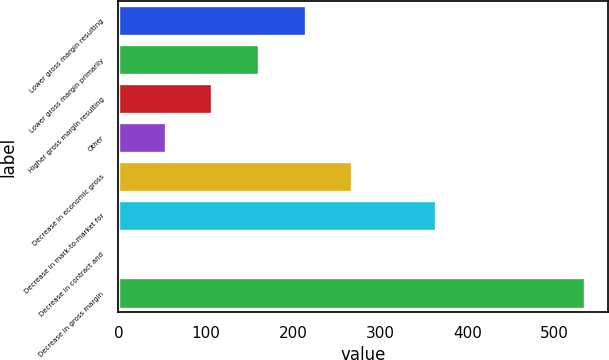<chart> <loc_0><loc_0><loc_500><loc_500><bar_chart><fcel>Lower gross margin resulting<fcel>Lower gross margin primarily<fcel>Higher gross margin resulting<fcel>Other<fcel>Decrease in economic gross<fcel>Decrease in mark-to-market for<fcel>Decrease in contract and<fcel>Decrease in gross margin<nl><fcel>214.6<fcel>161.2<fcel>107.8<fcel>54.4<fcel>268<fcel>364<fcel>1<fcel>535<nl></chart> 